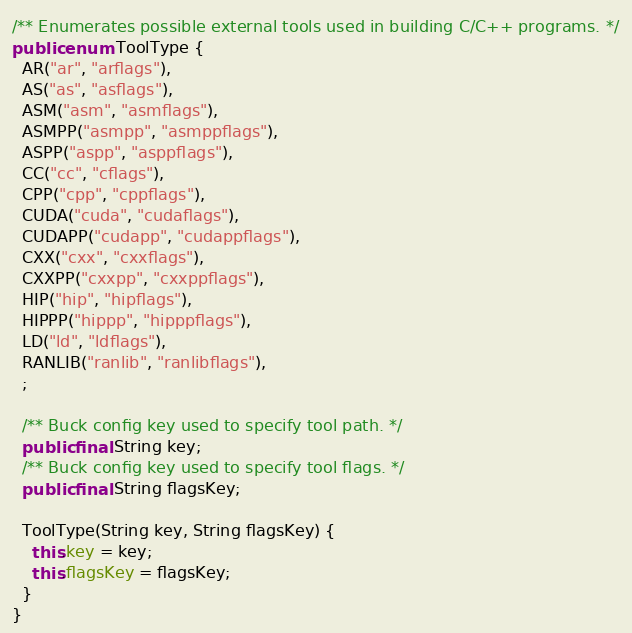Convert code to text. <code><loc_0><loc_0><loc_500><loc_500><_Java_>
/** Enumerates possible external tools used in building C/C++ programs. */
public enum ToolType {
  AR("ar", "arflags"),
  AS("as", "asflags"),
  ASM("asm", "asmflags"),
  ASMPP("asmpp", "asmppflags"),
  ASPP("aspp", "asppflags"),
  CC("cc", "cflags"),
  CPP("cpp", "cppflags"),
  CUDA("cuda", "cudaflags"),
  CUDAPP("cudapp", "cudappflags"),
  CXX("cxx", "cxxflags"),
  CXXPP("cxxpp", "cxxppflags"),
  HIP("hip", "hipflags"),
  HIPPP("hippp", "hipppflags"),
  LD("ld", "ldflags"),
  RANLIB("ranlib", "ranlibflags"),
  ;

  /** Buck config key used to specify tool path. */
  public final String key;
  /** Buck config key used to specify tool flags. */
  public final String flagsKey;

  ToolType(String key, String flagsKey) {
    this.key = key;
    this.flagsKey = flagsKey;
  }
}
</code> 